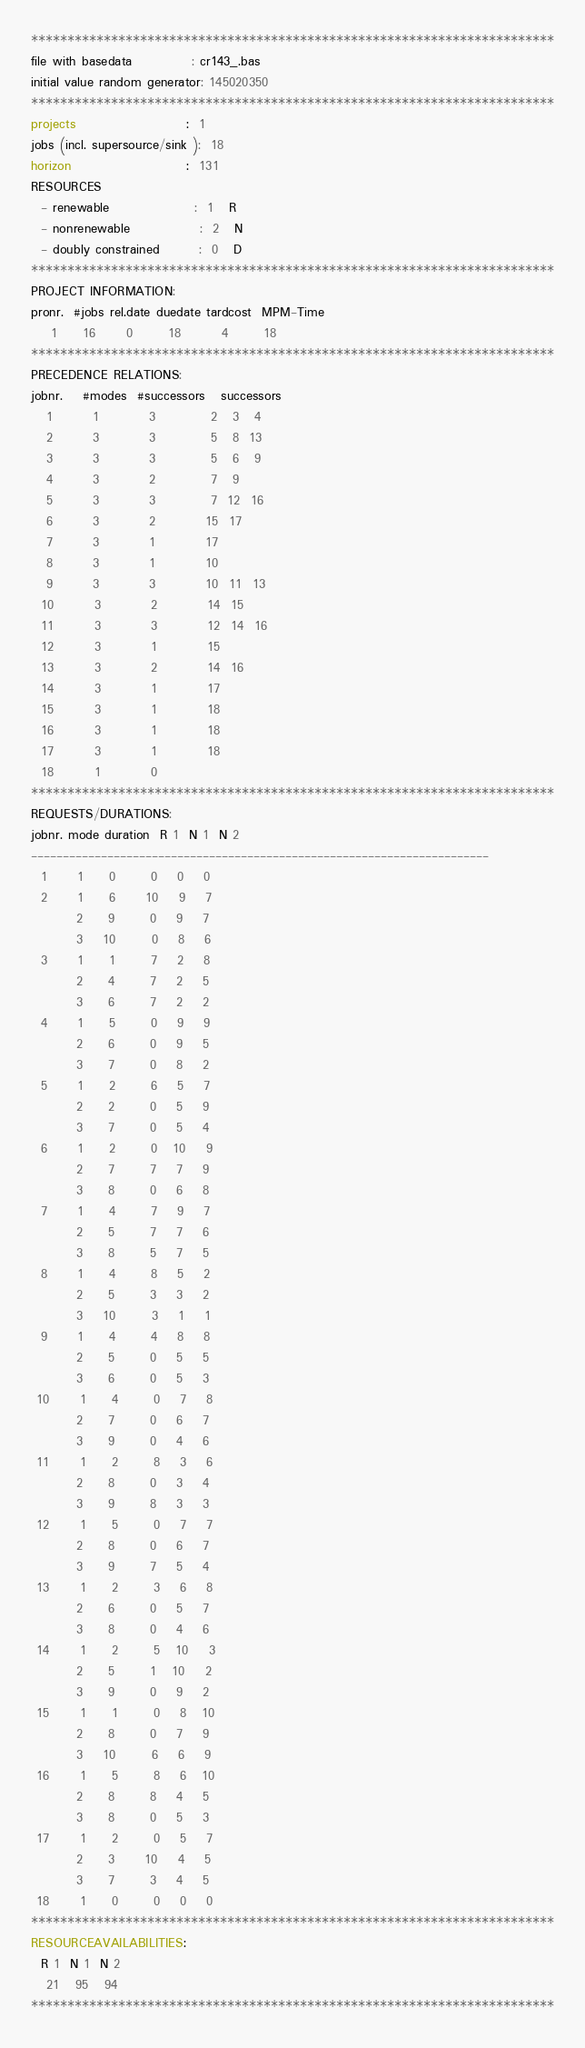<code> <loc_0><loc_0><loc_500><loc_500><_ObjectiveC_>************************************************************************
file with basedata            : cr143_.bas
initial value random generator: 145020350
************************************************************************
projects                      :  1
jobs (incl. supersource/sink ):  18
horizon                       :  131
RESOURCES
  - renewable                 :  1   R
  - nonrenewable              :  2   N
  - doubly constrained        :  0   D
************************************************************************
PROJECT INFORMATION:
pronr.  #jobs rel.date duedate tardcost  MPM-Time
    1     16      0       18        4       18
************************************************************************
PRECEDENCE RELATIONS:
jobnr.    #modes  #successors   successors
   1        1          3           2   3   4
   2        3          3           5   8  13
   3        3          3           5   6   9
   4        3          2           7   9
   5        3          3           7  12  16
   6        3          2          15  17
   7        3          1          17
   8        3          1          10
   9        3          3          10  11  13
  10        3          2          14  15
  11        3          3          12  14  16
  12        3          1          15
  13        3          2          14  16
  14        3          1          17
  15        3          1          18
  16        3          1          18
  17        3          1          18
  18        1          0        
************************************************************************
REQUESTS/DURATIONS:
jobnr. mode duration  R 1  N 1  N 2
------------------------------------------------------------------------
  1      1     0       0    0    0
  2      1     6      10    9    7
         2     9       0    9    7
         3    10       0    8    6
  3      1     1       7    2    8
         2     4       7    2    5
         3     6       7    2    2
  4      1     5       0    9    9
         2     6       0    9    5
         3     7       0    8    2
  5      1     2       6    5    7
         2     2       0    5    9
         3     7       0    5    4
  6      1     2       0   10    9
         2     7       7    7    9
         3     8       0    6    8
  7      1     4       7    9    7
         2     5       7    7    6
         3     8       5    7    5
  8      1     4       8    5    2
         2     5       3    3    2
         3    10       3    1    1
  9      1     4       4    8    8
         2     5       0    5    5
         3     6       0    5    3
 10      1     4       0    7    8
         2     7       0    6    7
         3     9       0    4    6
 11      1     2       8    3    6
         2     8       0    3    4
         3     9       8    3    3
 12      1     5       0    7    7
         2     8       0    6    7
         3     9       7    5    4
 13      1     2       3    6    8
         2     6       0    5    7
         3     8       0    4    6
 14      1     2       5   10    3
         2     5       1   10    2
         3     9       0    9    2
 15      1     1       0    8   10
         2     8       0    7    9
         3    10       6    6    9
 16      1     5       8    6   10
         2     8       8    4    5
         3     8       0    5    3
 17      1     2       0    5    7
         2     3      10    4    5
         3     7       3    4    5
 18      1     0       0    0    0
************************************************************************
RESOURCEAVAILABILITIES:
  R 1  N 1  N 2
   21   95   94
************************************************************************
</code> 